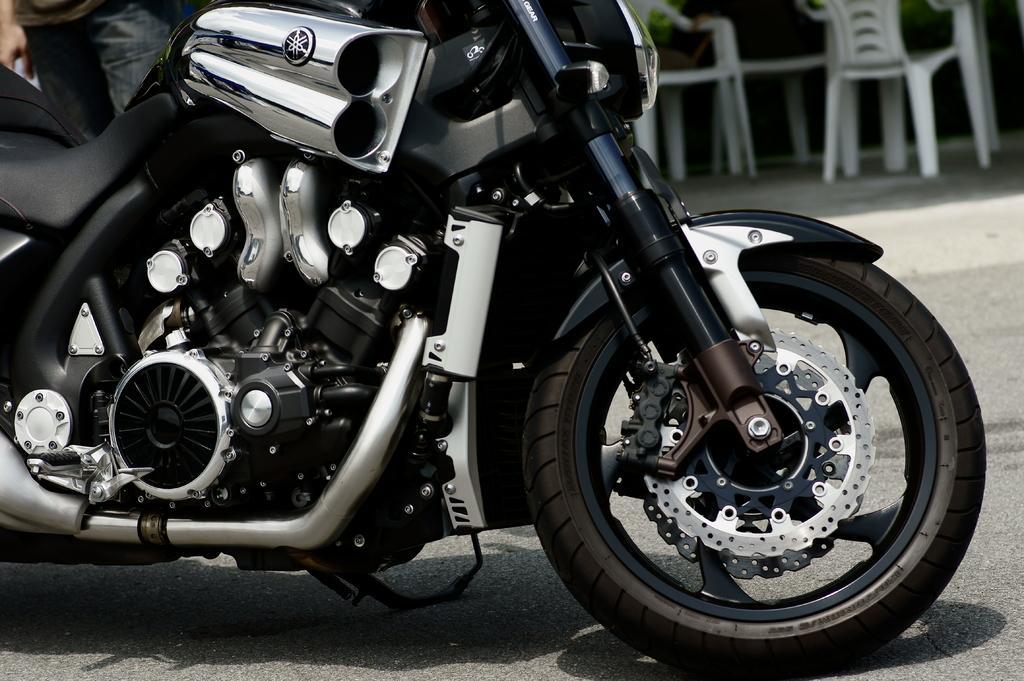How would you summarize this image in a sentence or two? Here we can see a motor cycle on the road, and a person is standing, and here are the chairs. 